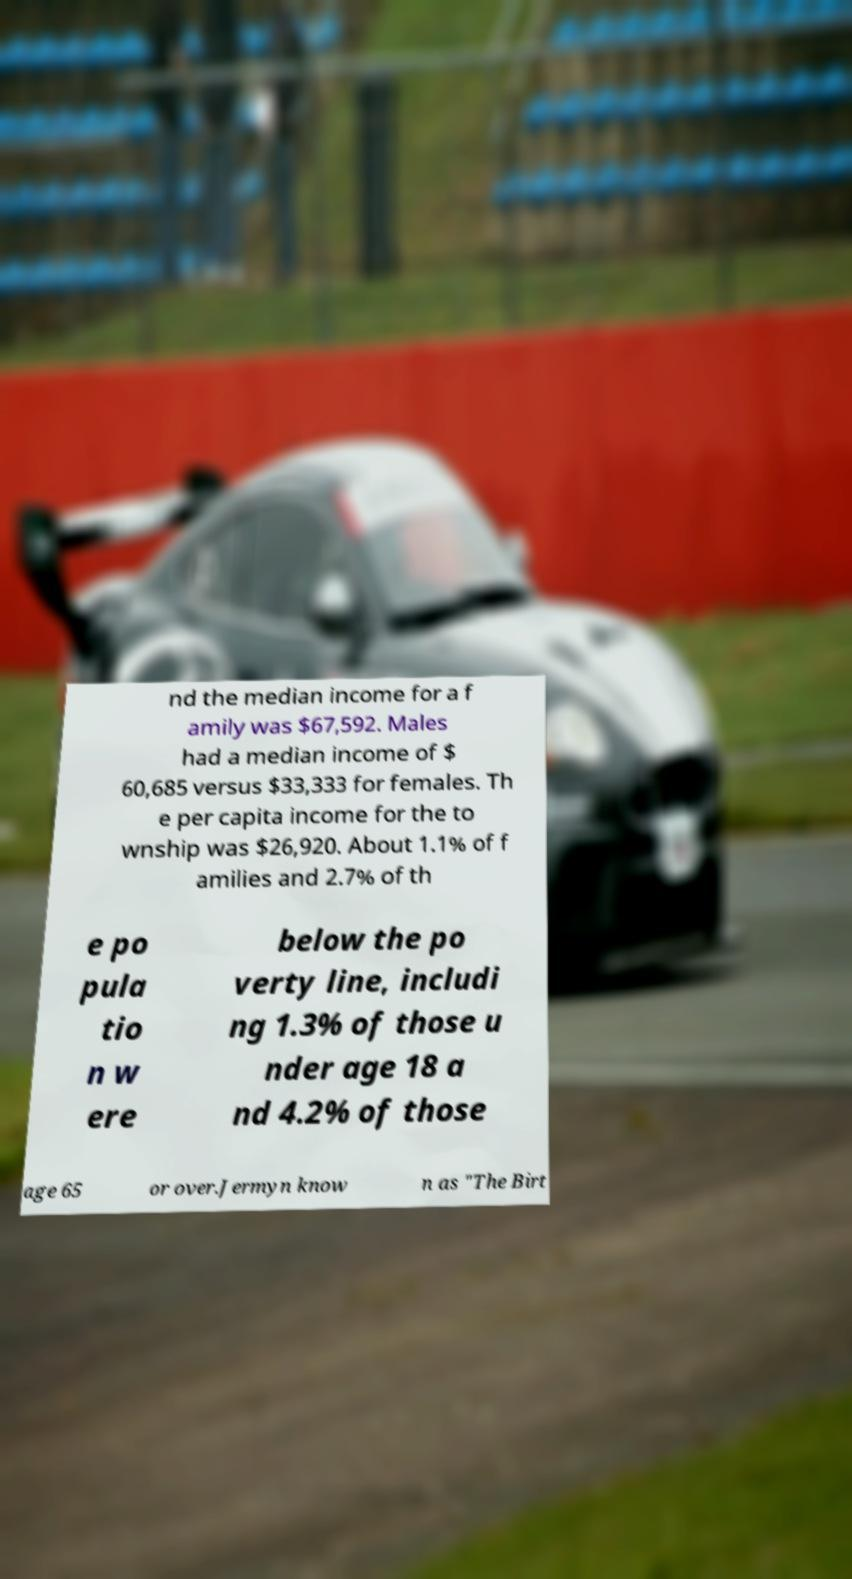Can you accurately transcribe the text from the provided image for me? nd the median income for a f amily was $67,592. Males had a median income of $ 60,685 versus $33,333 for females. Th e per capita income for the to wnship was $26,920. About 1.1% of f amilies and 2.7% of th e po pula tio n w ere below the po verty line, includi ng 1.3% of those u nder age 18 a nd 4.2% of those age 65 or over.Jermyn know n as "The Birt 